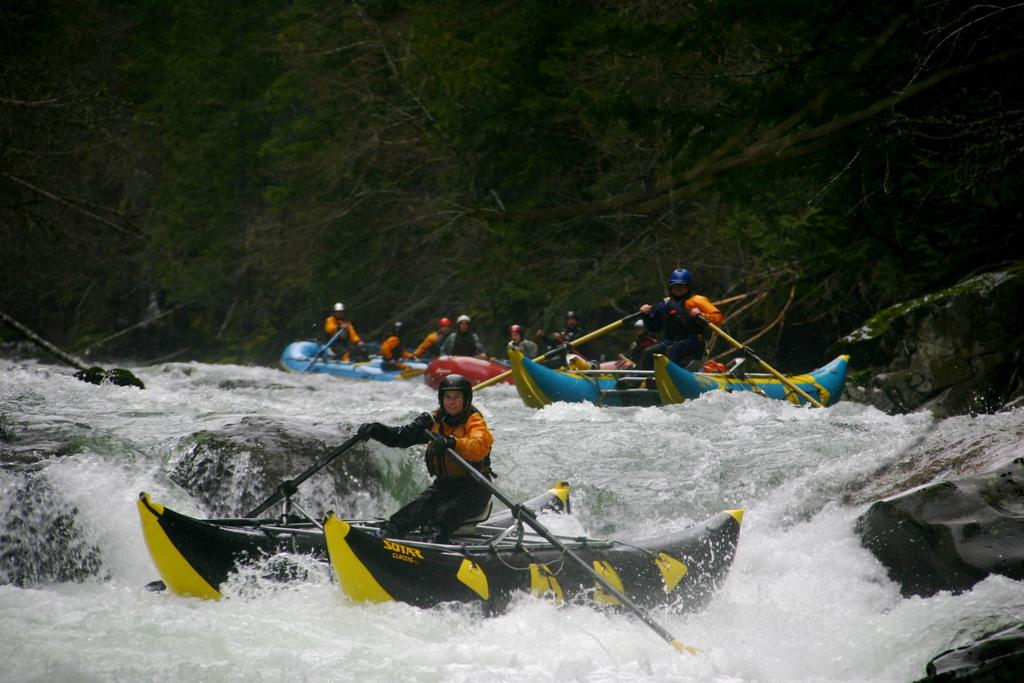What is happening in the image? There is water flow in the image, and boats are present. Who is in the boats? There are people sitting in the boats. What can be seen in the background of the image? Trees are visible in the image. What type of field can be seen in the image? There is no field present in the image; it features water flow and boats with people sitting in them. 